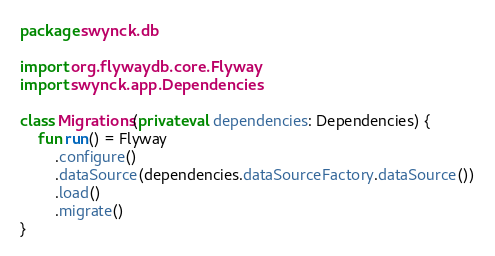Convert code to text. <code><loc_0><loc_0><loc_500><loc_500><_Kotlin_>package swynck.db

import org.flywaydb.core.Flyway
import swynck.app.Dependencies

class Migrations(private val dependencies: Dependencies) {
    fun run() = Flyway
        .configure()
        .dataSource(dependencies.dataSourceFactory.dataSource())
        .load()
        .migrate()
}</code> 